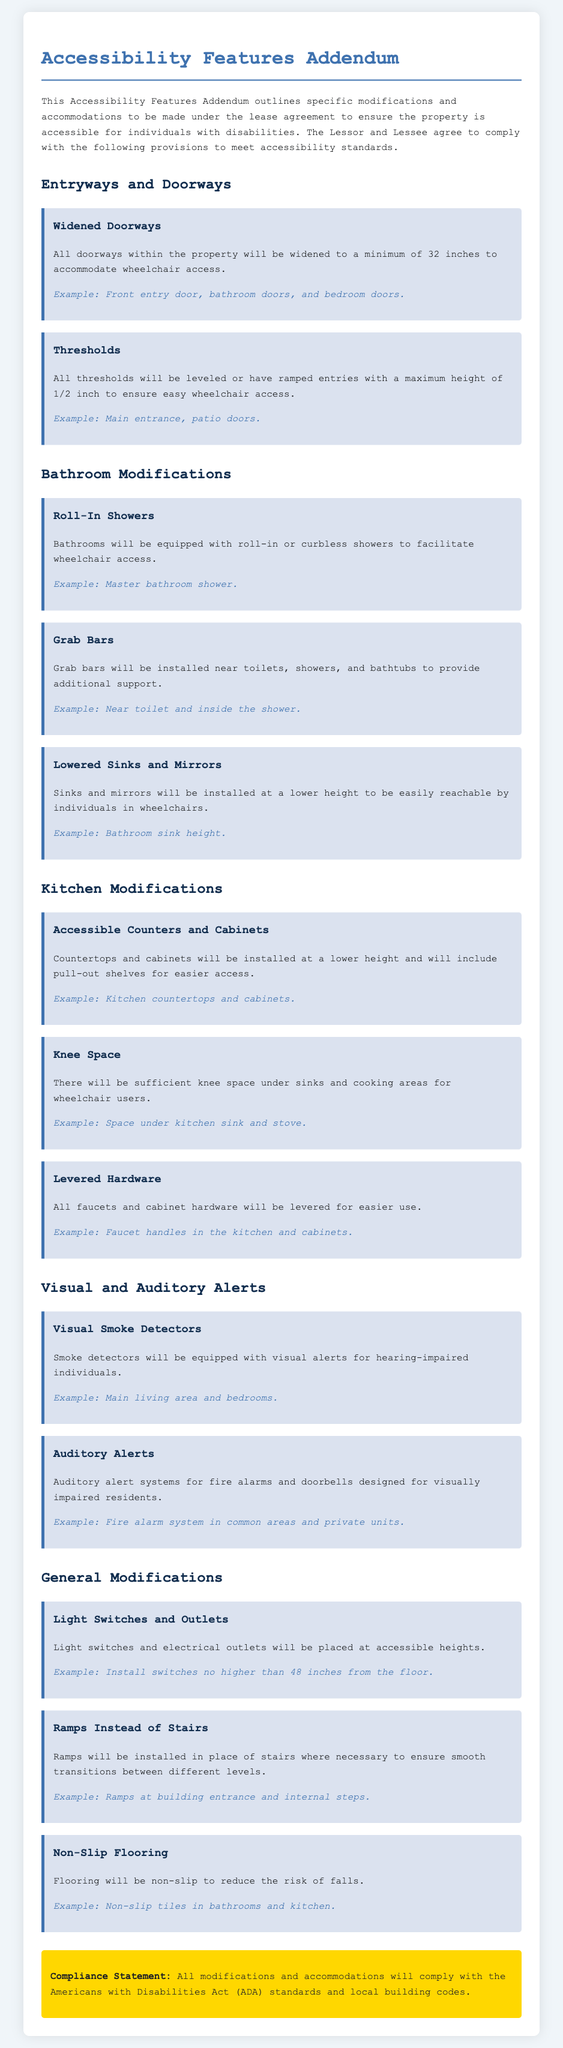What is the minimum width for doorways? The document specifies that all doorways will be widened to a minimum of 32 inches.
Answer: 32 inches What type of shower is required in the bathrooms? The document states that bathrooms will be equipped with roll-in or curbless showers.
Answer: Roll-in showers What height should light switches be installed at? The document specifies that light switches should be installed no higher than 48 inches from the floor.
Answer: 48 inches What feature provides support near toilets and showers? The addendum requires grab bars to be installed near toilets, showers, and bathtubs for additional support.
Answer: Grab bars What modification will replace stairs where necessary? The document states that ramps will be installed in place of stairs to ensure smooth transitions.
Answer: Ramps What type of flooring is recommended to reduce fall risks? The document specifies that flooring will be non-slip to reduce the risk of falls.
Answer: Non-slip Which feature is designed for hearing-impaired individuals? The document mentions that smoke detectors will be equipped with visual alerts for hearing-impaired individuals.
Answer: Visual smoke detectors How will kitchen countertops be modified? The text indicates that countertops will be installed at a lower height and will include pull-out shelves for easier access.
Answer: Lower height and pull-out shelves What safety feature is included for visually impaired residents? The addendum mentions auditory alert systems for fire alarms and doorbells designed for visually impaired residents.
Answer: Auditory alerts 